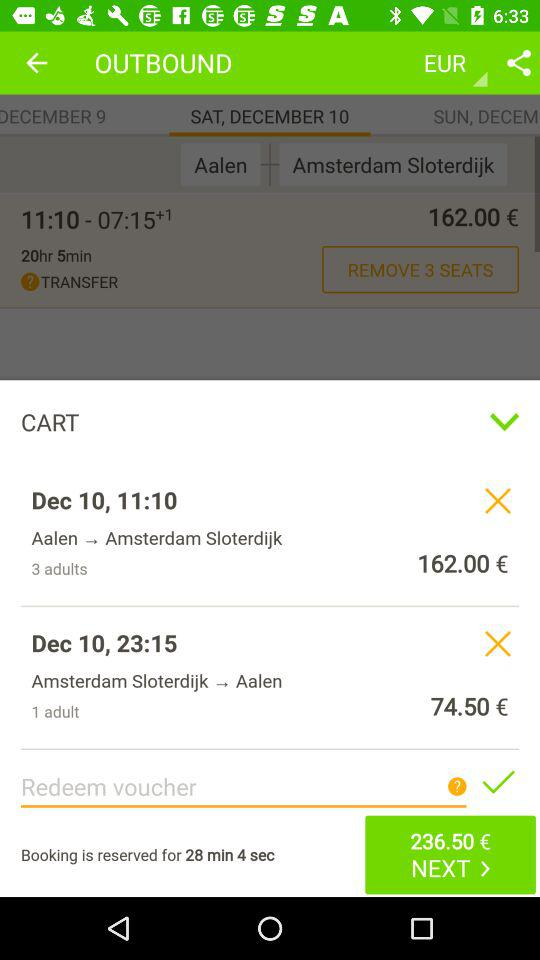At what time did the train leave Aalen? The time is "11:10". 